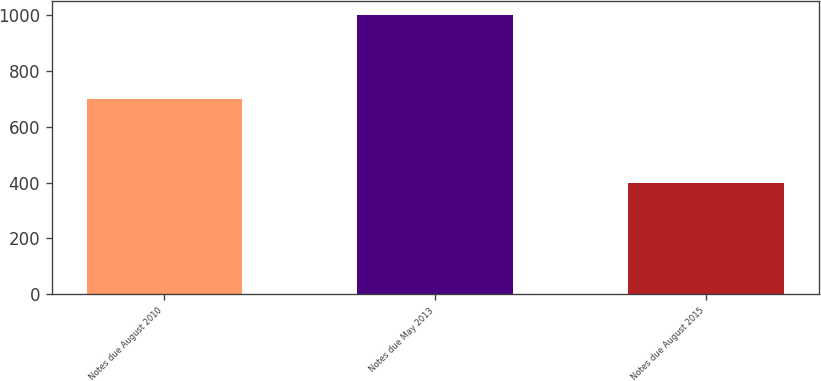<chart> <loc_0><loc_0><loc_500><loc_500><bar_chart><fcel>Notes due August 2010<fcel>Notes due May 2013<fcel>Notes due August 2015<nl><fcel>699<fcel>999<fcel>400<nl></chart> 